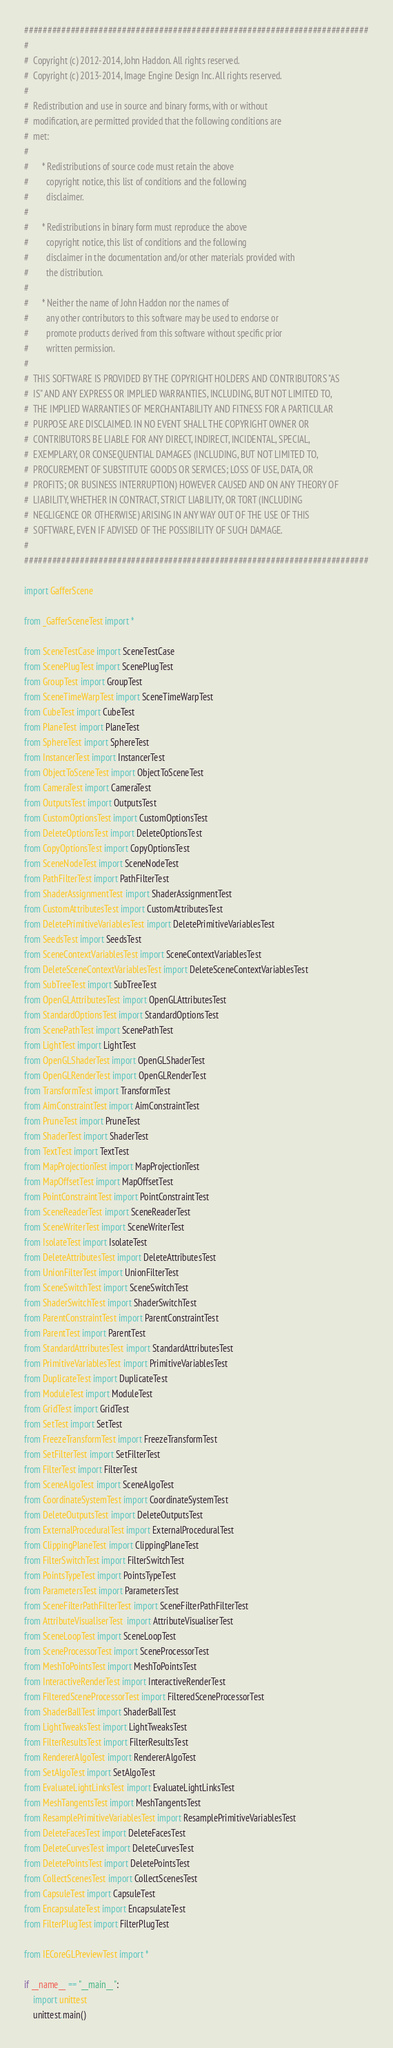Convert code to text. <code><loc_0><loc_0><loc_500><loc_500><_Python_>##########################################################################
#
#  Copyright (c) 2012-2014, John Haddon. All rights reserved.
#  Copyright (c) 2013-2014, Image Engine Design Inc. All rights reserved.
#
#  Redistribution and use in source and binary forms, with or without
#  modification, are permitted provided that the following conditions are
#  met:
#
#      * Redistributions of source code must retain the above
#        copyright notice, this list of conditions and the following
#        disclaimer.
#
#      * Redistributions in binary form must reproduce the above
#        copyright notice, this list of conditions and the following
#        disclaimer in the documentation and/or other materials provided with
#        the distribution.
#
#      * Neither the name of John Haddon nor the names of
#        any other contributors to this software may be used to endorse or
#        promote products derived from this software without specific prior
#        written permission.
#
#  THIS SOFTWARE IS PROVIDED BY THE COPYRIGHT HOLDERS AND CONTRIBUTORS "AS
#  IS" AND ANY EXPRESS OR IMPLIED WARRANTIES, INCLUDING, BUT NOT LIMITED TO,
#  THE IMPLIED WARRANTIES OF MERCHANTABILITY AND FITNESS FOR A PARTICULAR
#  PURPOSE ARE DISCLAIMED. IN NO EVENT SHALL THE COPYRIGHT OWNER OR
#  CONTRIBUTORS BE LIABLE FOR ANY DIRECT, INDIRECT, INCIDENTAL, SPECIAL,
#  EXEMPLARY, OR CONSEQUENTIAL DAMAGES (INCLUDING, BUT NOT LIMITED TO,
#  PROCUREMENT OF SUBSTITUTE GOODS OR SERVICES; LOSS OF USE, DATA, OR
#  PROFITS; OR BUSINESS INTERRUPTION) HOWEVER CAUSED AND ON ANY THEORY OF
#  LIABILITY, WHETHER IN CONTRACT, STRICT LIABILITY, OR TORT (INCLUDING
#  NEGLIGENCE OR OTHERWISE) ARISING IN ANY WAY OUT OF THE USE OF THIS
#  SOFTWARE, EVEN IF ADVISED OF THE POSSIBILITY OF SUCH DAMAGE.
#
##########################################################################

import GafferScene

from _GafferSceneTest import *

from SceneTestCase import SceneTestCase
from ScenePlugTest import ScenePlugTest
from GroupTest import GroupTest
from SceneTimeWarpTest import SceneTimeWarpTest
from CubeTest import CubeTest
from PlaneTest import PlaneTest
from SphereTest import SphereTest
from InstancerTest import InstancerTest
from ObjectToSceneTest import ObjectToSceneTest
from CameraTest import CameraTest
from OutputsTest import OutputsTest
from CustomOptionsTest import CustomOptionsTest
from DeleteOptionsTest import DeleteOptionsTest
from CopyOptionsTest import CopyOptionsTest
from SceneNodeTest import SceneNodeTest
from PathFilterTest import PathFilterTest
from ShaderAssignmentTest import ShaderAssignmentTest
from CustomAttributesTest import CustomAttributesTest
from DeletePrimitiveVariablesTest import DeletePrimitiveVariablesTest
from SeedsTest import SeedsTest
from SceneContextVariablesTest import SceneContextVariablesTest
from DeleteSceneContextVariablesTest import DeleteSceneContextVariablesTest
from SubTreeTest import SubTreeTest
from OpenGLAttributesTest import OpenGLAttributesTest
from StandardOptionsTest import StandardOptionsTest
from ScenePathTest import ScenePathTest
from LightTest import LightTest
from OpenGLShaderTest import OpenGLShaderTest
from OpenGLRenderTest import OpenGLRenderTest
from TransformTest import TransformTest
from AimConstraintTest import AimConstraintTest
from PruneTest import PruneTest
from ShaderTest import ShaderTest
from TextTest import TextTest
from MapProjectionTest import MapProjectionTest
from MapOffsetTest import MapOffsetTest
from PointConstraintTest import PointConstraintTest
from SceneReaderTest import SceneReaderTest
from SceneWriterTest import SceneWriterTest
from IsolateTest import IsolateTest
from DeleteAttributesTest import DeleteAttributesTest
from UnionFilterTest import UnionFilterTest
from SceneSwitchTest import SceneSwitchTest
from ShaderSwitchTest import ShaderSwitchTest
from ParentConstraintTest import ParentConstraintTest
from ParentTest import ParentTest
from StandardAttributesTest import StandardAttributesTest
from PrimitiveVariablesTest import PrimitiveVariablesTest
from DuplicateTest import DuplicateTest
from ModuleTest import ModuleTest
from GridTest import GridTest
from SetTest import SetTest
from FreezeTransformTest import FreezeTransformTest
from SetFilterTest import SetFilterTest
from FilterTest import FilterTest
from SceneAlgoTest import SceneAlgoTest
from CoordinateSystemTest import CoordinateSystemTest
from DeleteOutputsTest import DeleteOutputsTest
from ExternalProceduralTest import ExternalProceduralTest
from ClippingPlaneTest import ClippingPlaneTest
from FilterSwitchTest import FilterSwitchTest
from PointsTypeTest import PointsTypeTest
from ParametersTest import ParametersTest
from SceneFilterPathFilterTest import SceneFilterPathFilterTest
from AttributeVisualiserTest  import AttributeVisualiserTest
from SceneLoopTest import SceneLoopTest
from SceneProcessorTest import SceneProcessorTest
from MeshToPointsTest import MeshToPointsTest
from InteractiveRenderTest import InteractiveRenderTest
from FilteredSceneProcessorTest import FilteredSceneProcessorTest
from ShaderBallTest import ShaderBallTest
from LightTweaksTest import LightTweaksTest
from FilterResultsTest import FilterResultsTest
from RendererAlgoTest import RendererAlgoTest
from SetAlgoTest import SetAlgoTest
from EvaluateLightLinksTest import EvaluateLightLinksTest
from MeshTangentsTest import MeshTangentsTest
from ResamplePrimitiveVariablesTest import ResamplePrimitiveVariablesTest
from DeleteFacesTest import DeleteFacesTest
from DeleteCurvesTest import DeleteCurvesTest
from DeletePointsTest import DeletePointsTest
from CollectScenesTest import CollectScenesTest
from CapsuleTest import CapsuleTest
from EncapsulateTest import EncapsulateTest
from FilterPlugTest import FilterPlugTest

from IECoreGLPreviewTest import *

if __name__ == "__main__":
	import unittest
	unittest.main()
</code> 